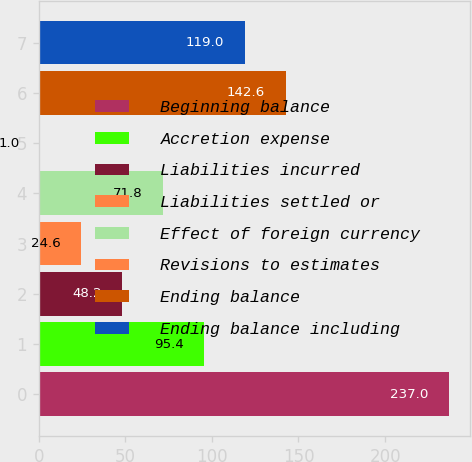Convert chart to OTSL. <chart><loc_0><loc_0><loc_500><loc_500><bar_chart><fcel>Beginning balance<fcel>Accretion expense<fcel>Liabilities incurred<fcel>Liabilities settled or<fcel>Effect of foreign currency<fcel>Revisions to estimates<fcel>Ending balance<fcel>Ending balance including<nl><fcel>237<fcel>95.4<fcel>48.2<fcel>24.6<fcel>71.8<fcel>1<fcel>142.6<fcel>119<nl></chart> 